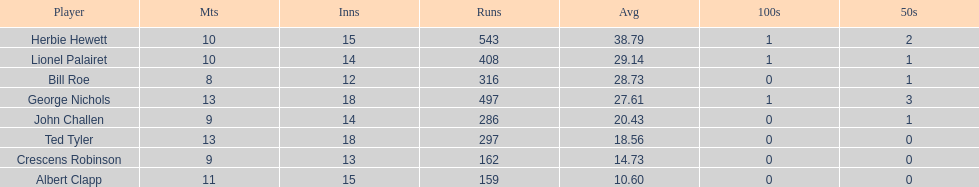Name a player that play in no more than 13 innings. Bill Roe. 